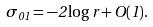<formula> <loc_0><loc_0><loc_500><loc_500>\sigma _ { 0 1 } = - 2 \log r + O ( 1 ) .</formula> 